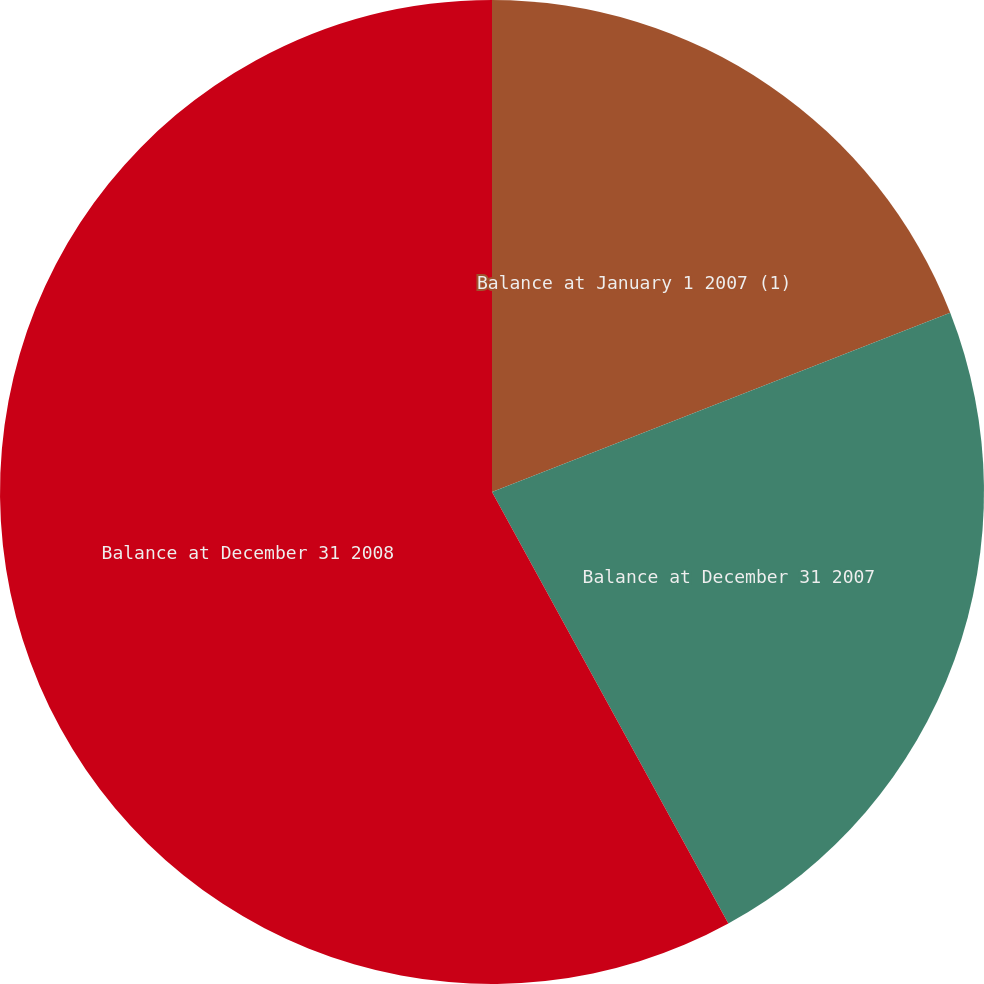Convert chart. <chart><loc_0><loc_0><loc_500><loc_500><pie_chart><fcel>Balance at January 1 2007 (1)<fcel>Balance at December 31 2007<fcel>Balance at December 31 2008<nl><fcel>19.07%<fcel>22.96%<fcel>57.98%<nl></chart> 